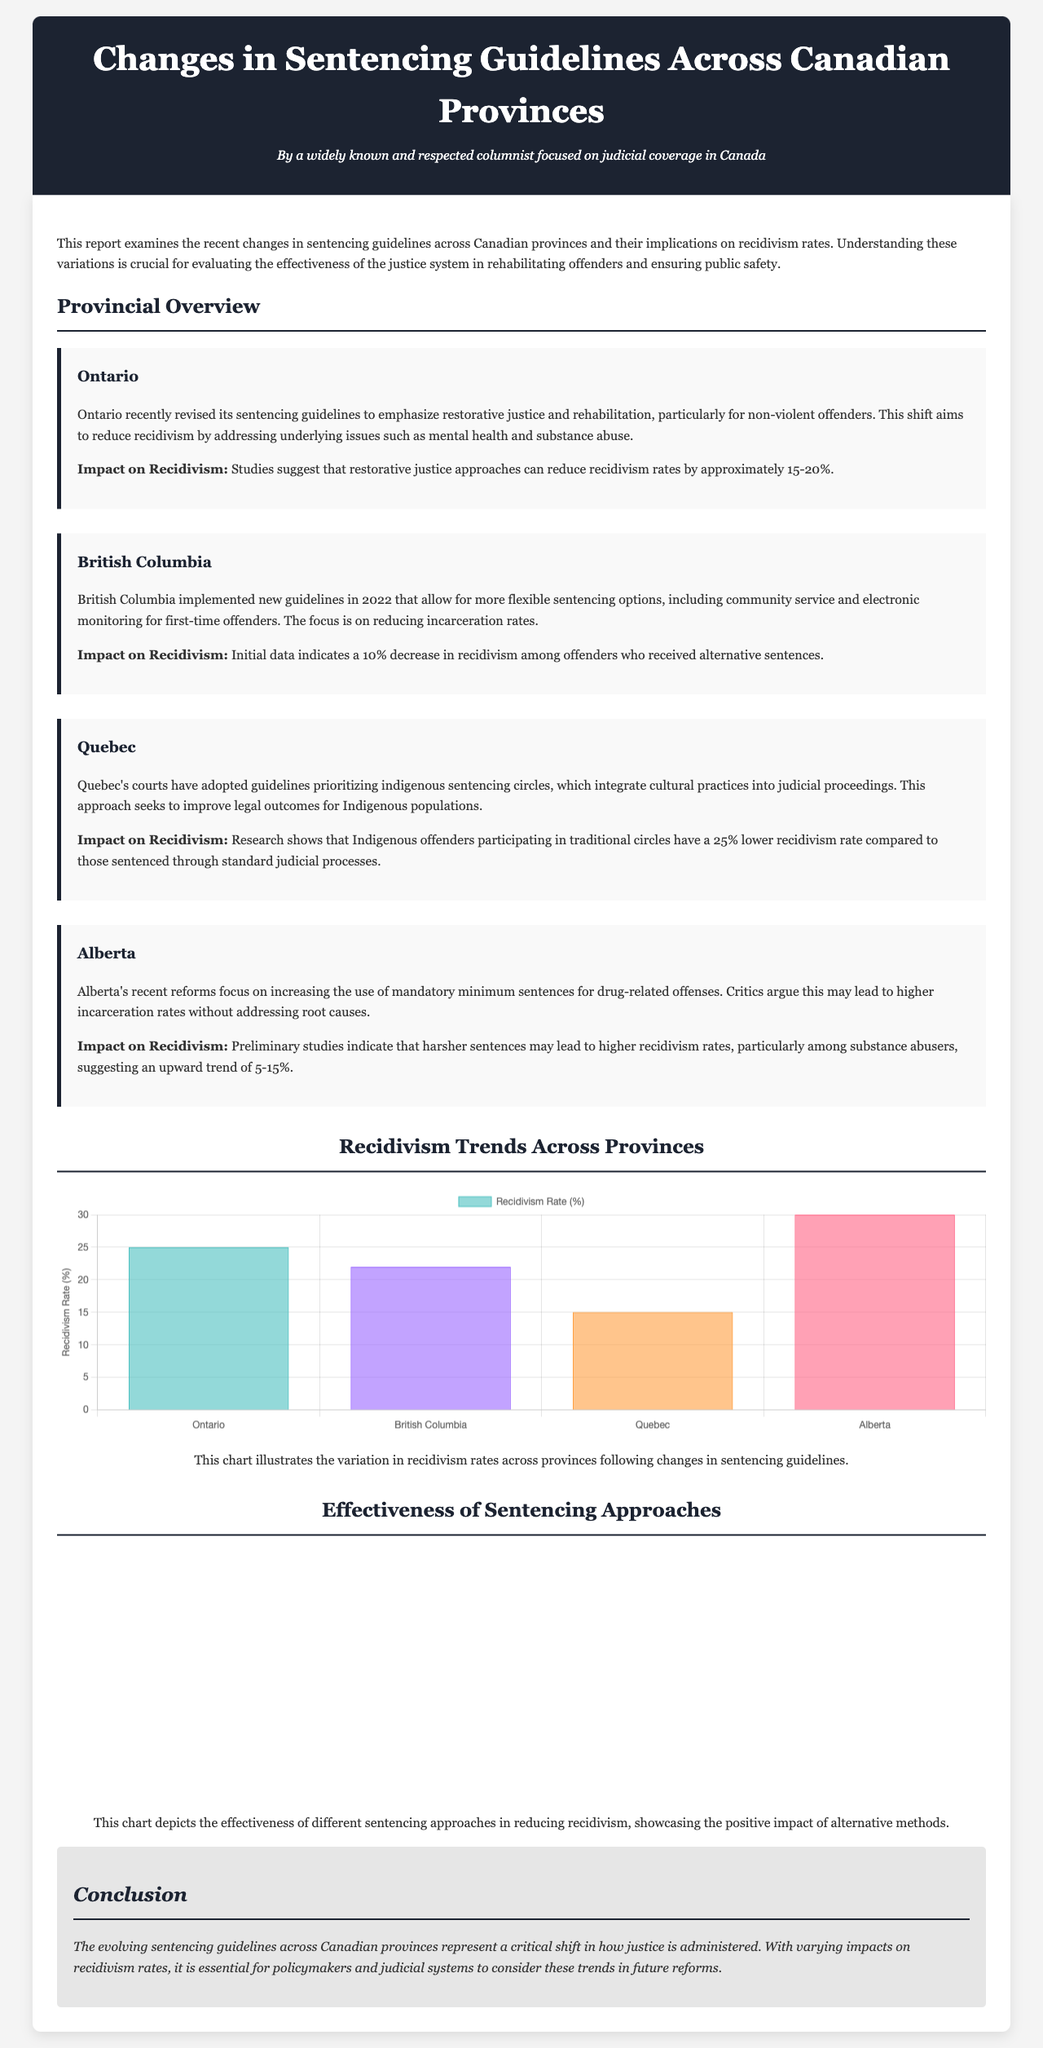What is the primary focus of the report? The report examines the recent changes in sentencing guidelines across Canadian provinces and their implications on recidivism rates.
Answer: Sentencing guidelines and recidivism What percentage reduction in recidivism is suggested for Ontario's restorative justice approach? Studies suggest that restorative justice approaches can reduce recidivism rates by approximately 15-20%.
Answer: 15-20% Which province's guidelines prioritize indigenous sentencing circles? Quebec's courts have adopted guidelines prioritizing indigenous sentencing circles.
Answer: Quebec What is the recidivism rate percentage for British Columbia? The chart indicates that British Columbia has a recidivism rate of 22%.
Answer: 22% What is the effectiveness percentage of community-based sentencing? The chart shows that community-based sentencing has an effectiveness percentage of 70%.
Answer: 70% How much lower is the recidivism rate for Indigenous offenders participating in traditional circles compared to standard judicial processes? Research shows that Indigenous offenders participating in traditional circles have a 25% lower recidivism rate compared to those sentenced through standard judicial processes.
Answer: 25% What potential impact does Alberta's increased use of mandatory minimum sentences have on recidivism? Preliminary studies indicate that harsher sentences may lead to higher recidivism rates, particularly among substance abusers.
Answer: Higher recidivism rates What type of chart depicts the effectiveness of different sentencing approaches? The chart depicting effectiveness is a horizontal bar chart.
Answer: Horizontal bar chart Which province's new guidelines include community service and electronic monitoring for first-time offenders? British Columbia implemented new guidelines that allow for more flexible sentencing options, including community service and electronic monitoring for first-time offenders.
Answer: British Columbia 